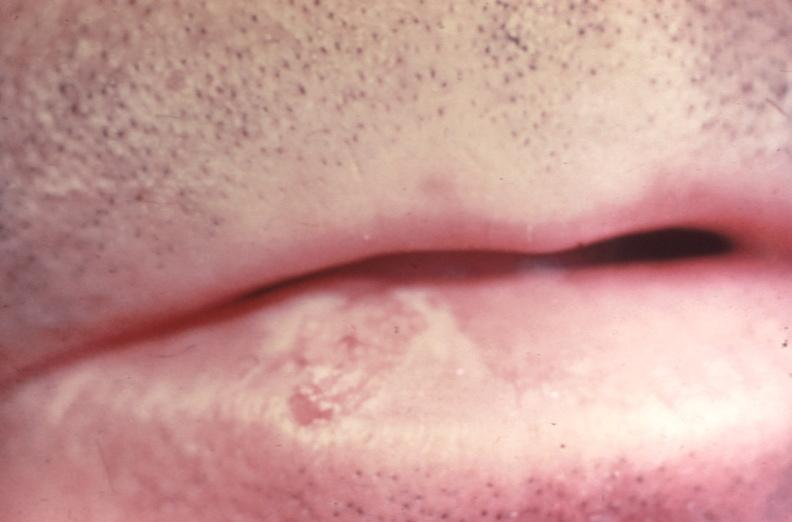does lateral view show squamous cell carcinoma, lip?
Answer the question using a single word or phrase. No 